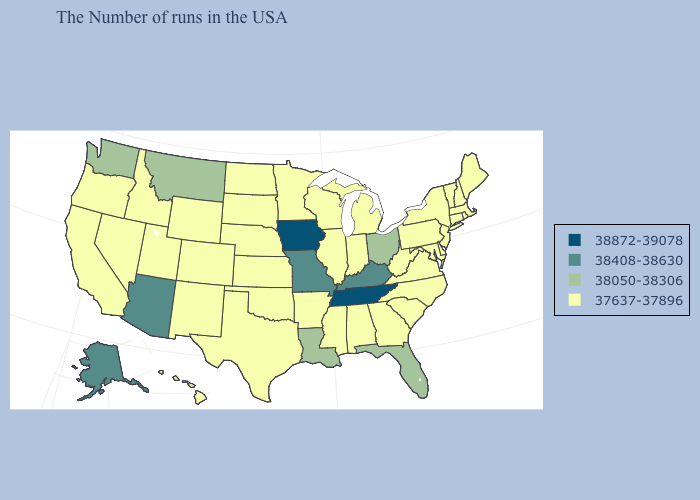How many symbols are there in the legend?
Give a very brief answer. 4. What is the value of Nevada?
Concise answer only. 37637-37896. Among the states that border New Jersey , which have the lowest value?
Give a very brief answer. New York, Delaware, Pennsylvania. Does Alaska have the lowest value in the USA?
Answer briefly. No. What is the value of Arkansas?
Give a very brief answer. 37637-37896. How many symbols are there in the legend?
Keep it brief. 4. What is the value of Massachusetts?
Answer briefly. 37637-37896. What is the value of Maine?
Give a very brief answer. 37637-37896. Among the states that border Minnesota , does Wisconsin have the lowest value?
Quick response, please. Yes. What is the lowest value in the USA?
Quick response, please. 37637-37896. Does Florida have the same value as North Carolina?
Quick response, please. No. Name the states that have a value in the range 38050-38306?
Give a very brief answer. Ohio, Florida, Louisiana, Montana, Washington. Which states have the highest value in the USA?
Concise answer only. Tennessee, Iowa. Is the legend a continuous bar?
Write a very short answer. No. 